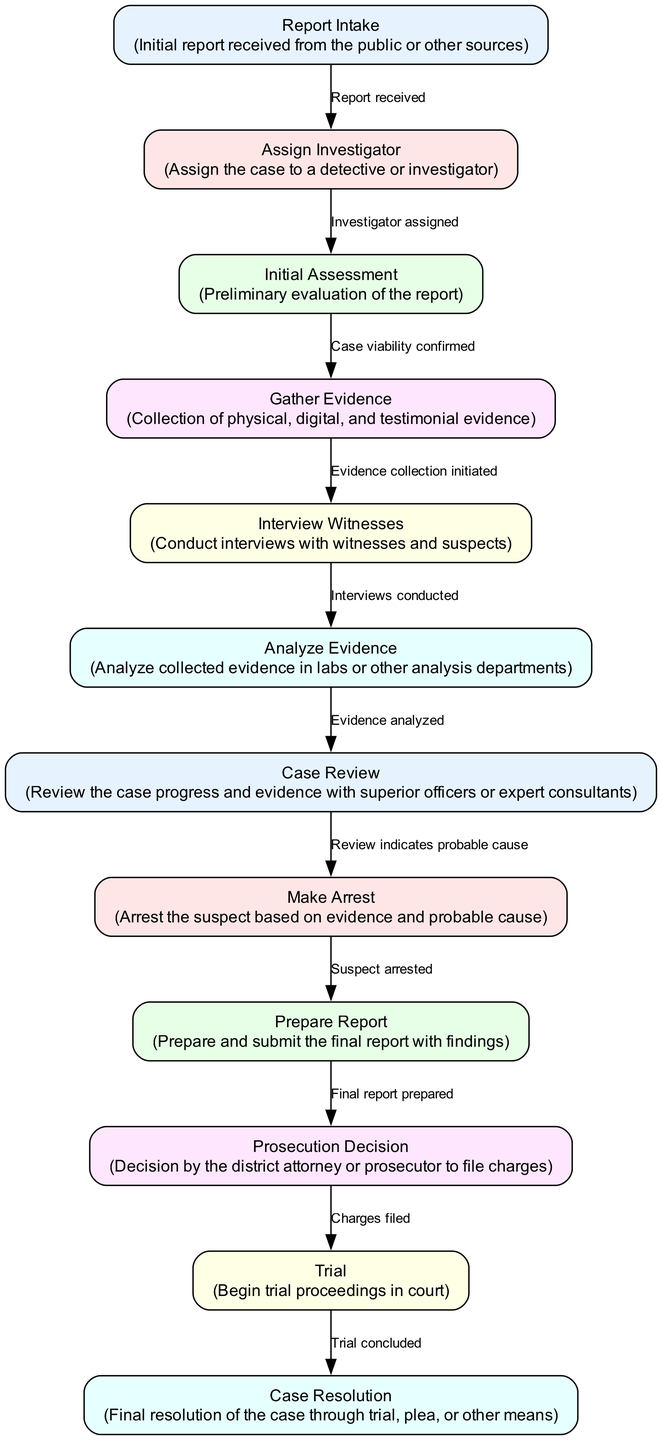What is the starting point of the workflow? The workflow begins with the "Report Intake" node, which represents the initial report received from the public or other sources.
Answer: Report Intake How many nodes are in the diagram? By counting the listed nodes in the diagram, we find that there are 11 distinct nodes that represent various stages in the case management workflow.
Answer: 11 What action follows the 'Initial Assessment' step? After the 'Initial Assessment', the next step in the workflow is 'Gather Evidence', which occurs if the case viability is confirmed.
Answer: Gather Evidence What does the 'Make Arrest' node indicate? The 'Make Arrest' node indicates that an arrest is made based on evidence and probable cause after reviewing the case previously.
Answer: Arrest What decision comes after the 'Prepare Report'? Following the 'Prepare Report' step, the 'Prosecution Decision' is made to determine whether to file charges based on the final report prepared.
Answer: Prosecution Decision Which two nodes are connected directly after 'Analyze Evidence'? After 'Analyze Evidence', there is a direct connection to 'Case Review', indicating that evidence analyzed leads to a review of the case progress and evidence.
Answer: Case Review How many edges connect to the 'Trial' node? The 'Trial' node has only one incoming edge, which comes from the 'Prosecution Decision' indicating that charges have been filed before the trial begins.
Answer: 1 What is the final outcome depicted in the diagram? The final outcome represented in the diagram is "Case Resolution", which signifies the closure of the case through trial, plea, or other means.
Answer: Case Resolution Which stage involves the interviewing of witnesses? The 'Interview Witnesses' node specifically describes the stage where witnesses and suspects are interviewed as part of the evidence collection process.
Answer: Interview Witnesses 